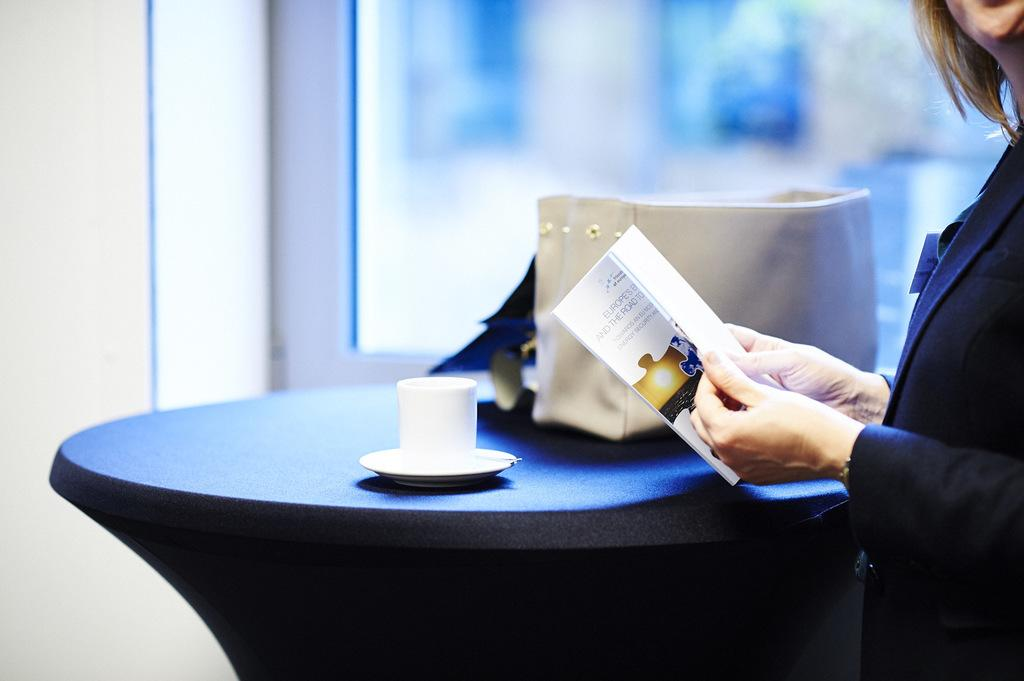What can be seen on the right side of the image? There is a woman on the right side of the image. What is the woman holding in her hands? The woman is holding a book in her hands. What is the woman wearing? The woman is wearing a black coat. What objects are on the table in the image? There is a tea cup and a saucer on the table. What type of jelly can be seen on the rose in the image? There is no jelly or rose present in the image. 